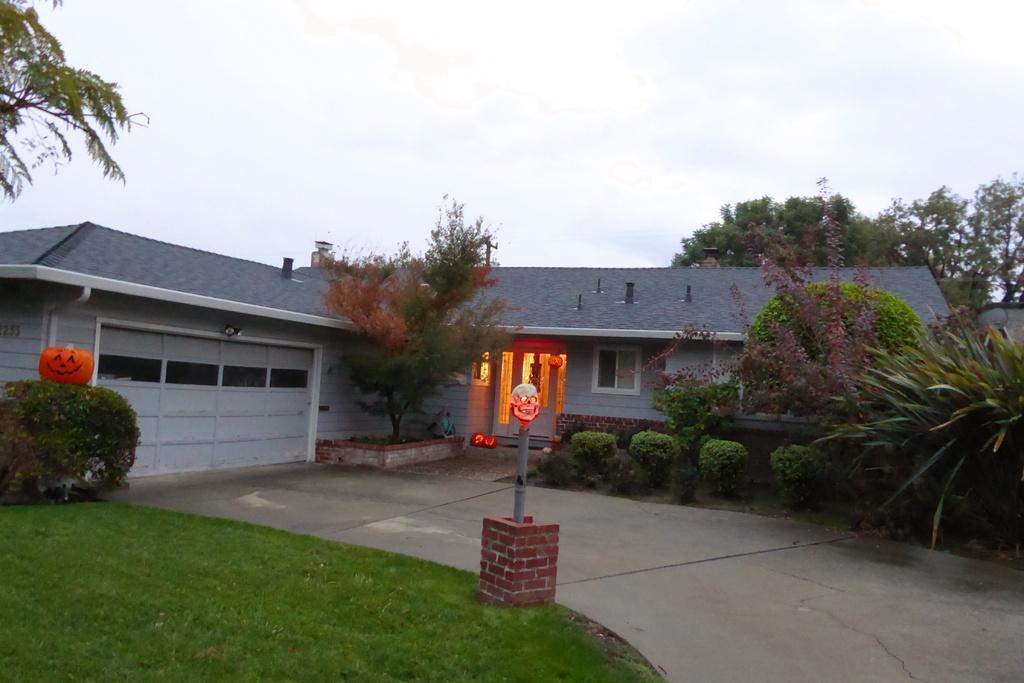How would you summarize this image in a sentence or two? In this image there is a road at the bottom. There is grass, there are trees, it looks like a house on the left corner. There are trees on the right corner. There is a house, there are windows, trees, there is a door and there are lights in the foreground. And there is sky at the top. 